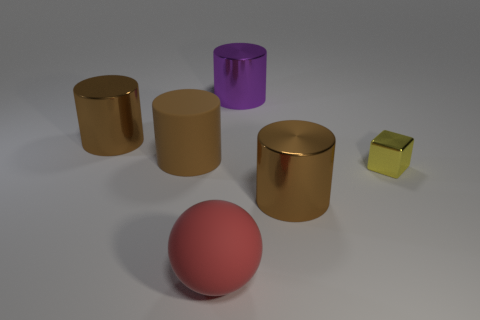Subtract all blue balls. How many brown cylinders are left? 3 Add 4 big purple cylinders. How many objects exist? 10 Subtract all spheres. How many objects are left? 5 Subtract 0 brown balls. How many objects are left? 6 Subtract all small blocks. Subtract all big red rubber things. How many objects are left? 4 Add 5 small yellow metallic cubes. How many small yellow metallic cubes are left? 6 Add 1 large brown metal cylinders. How many large brown metal cylinders exist? 3 